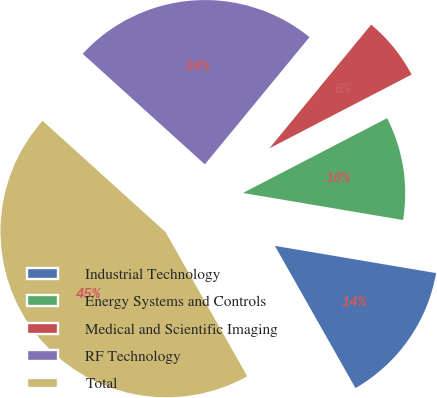Convert chart. <chart><loc_0><loc_0><loc_500><loc_500><pie_chart><fcel>Industrial Technology<fcel>Energy Systems and Controls<fcel>Medical and Scientific Imaging<fcel>RF Technology<fcel>Total<nl><fcel>14.13%<fcel>10.28%<fcel>6.43%<fcel>24.25%<fcel>44.91%<nl></chart> 